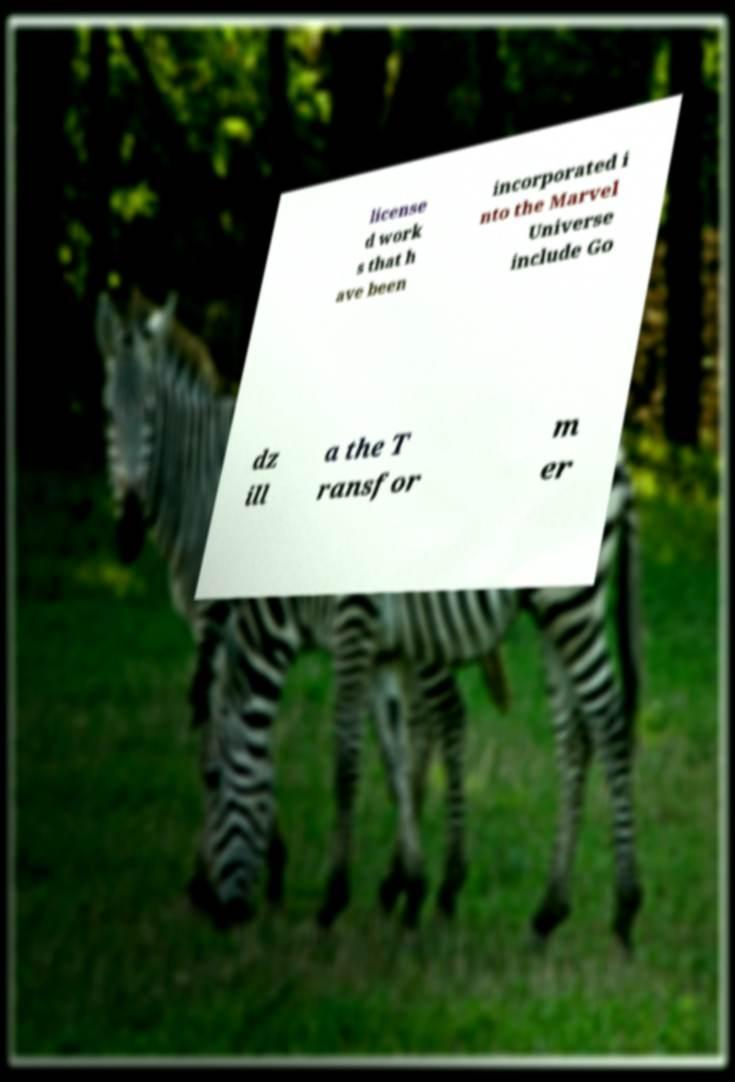For documentation purposes, I need the text within this image transcribed. Could you provide that? license d work s that h ave been incorporated i nto the Marvel Universe include Go dz ill a the T ransfor m er 